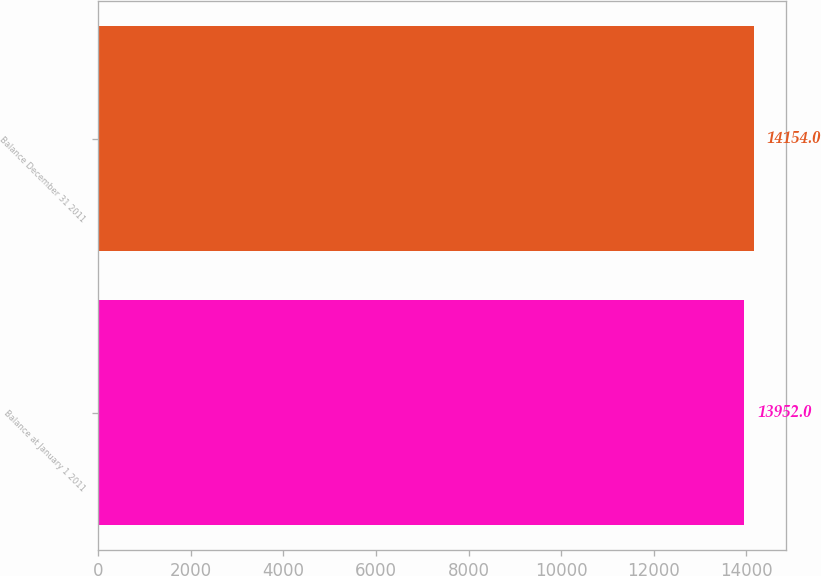Convert chart to OTSL. <chart><loc_0><loc_0><loc_500><loc_500><bar_chart><fcel>Balance at January 1 2011<fcel>Balance December 31 2011<nl><fcel>13952<fcel>14154<nl></chart> 